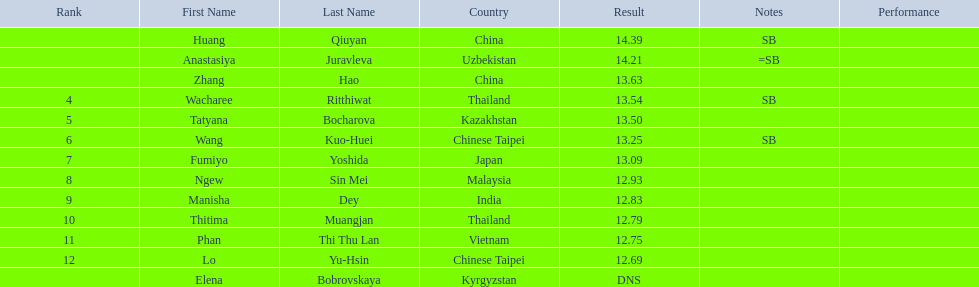I'm looking to parse the entire table for insights. Could you assist me with that? {'header': ['Rank', 'First Name', 'Last Name', 'Country', 'Result', 'Notes', 'Performance'], 'rows': [['', 'Huang', 'Qiuyan', 'China', '14.39', 'SB', ''], ['', 'Anastasiya', 'Juravleva', 'Uzbekistan', '14.21', '=SB', ''], ['', 'Zhang', 'Hao', 'China', '13.63', '', ''], ['4', 'Wacharee', 'Ritthiwat', 'Thailand', '13.54', 'SB', ''], ['5', 'Tatyana', 'Bocharova', 'Kazakhstan', '13.50', '', ''], ['6', 'Wang', 'Kuo-Huei', 'Chinese Taipei', '13.25', 'SB', ''], ['7', 'Fumiyo', 'Yoshida', 'Japan', '13.09', '', ''], ['8', 'Ngew', 'Sin Mei', 'Malaysia', '12.93', '', ''], ['9', 'Manisha', 'Dey', 'India', '12.83', '', ''], ['10', 'Thitima', 'Muangjan', 'Thailand', '12.79', '', ''], ['11', 'Phan', 'Thi Thu Lan', 'Vietnam', '12.75', '', ''], ['12', 'Lo', 'Yu-Hsin', 'Chinese Taipei', '12.69', '', ''], ['', 'Elena', 'Bobrovskaya', 'Kyrgyzstan', 'DNS', '', '']]} What is the difference between huang qiuyan's result and fumiyo yoshida's result? 1.3. 